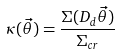<formula> <loc_0><loc_0><loc_500><loc_500>\kappa ( \vec { \theta } ) = \frac { \Sigma ( D _ { d } \vec { \theta } ) } { \Sigma _ { c r } }</formula> 